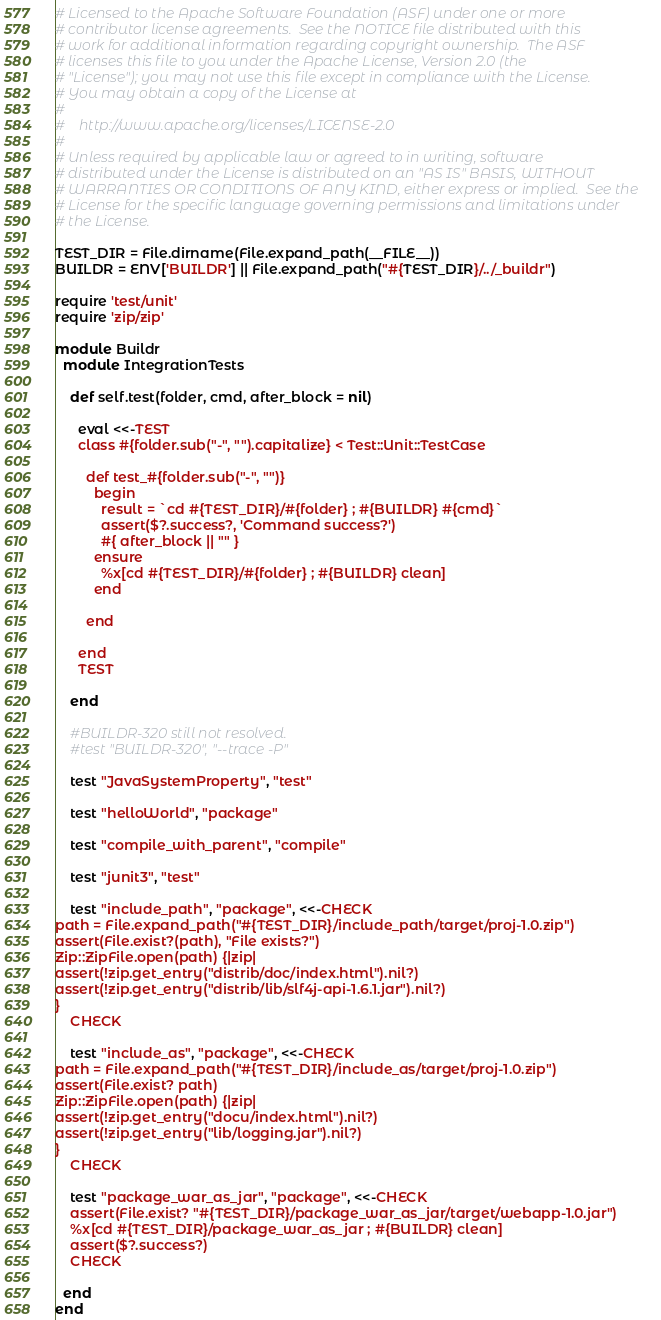Convert code to text. <code><loc_0><loc_0><loc_500><loc_500><_Ruby_># Licensed to the Apache Software Foundation (ASF) under one or more
# contributor license agreements.  See the NOTICE file distributed with this
# work for additional information regarding copyright ownership.  The ASF
# licenses this file to you under the Apache License, Version 2.0 (the
# "License"); you may not use this file except in compliance with the License.
# You may obtain a copy of the License at
#
#    http://www.apache.org/licenses/LICENSE-2.0
#
# Unless required by applicable law or agreed to in writing, software
# distributed under the License is distributed on an "AS IS" BASIS, WITHOUT
# WARRANTIES OR CONDITIONS OF ANY KIND, either express or implied.  See the
# License for the specific language governing permissions and limitations under
# the License.

TEST_DIR = File.dirname(File.expand_path(__FILE__))
BUILDR = ENV['BUILDR'] || File.expand_path("#{TEST_DIR}/../_buildr")

require 'test/unit'
require 'zip/zip'

module Buildr
  module IntegrationTests

    def self.test(folder, cmd, after_block = nil)

      eval <<-TEST
      class #{folder.sub("-", "").capitalize} < Test::Unit::TestCase

        def test_#{folder.sub("-", "")}
          begin
            result = `cd #{TEST_DIR}/#{folder} ; #{BUILDR} #{cmd}`
            assert($?.success?, 'Command success?')
            #{ after_block || "" }
          ensure
            %x[cd #{TEST_DIR}/#{folder} ; #{BUILDR} clean]
          end

        end

      end
      TEST

    end

    #BUILDR-320 still not resolved.
    #test "BUILDR-320", "--trace -P"

    test "JavaSystemProperty", "test"

    test "helloWorld", "package"

    test "compile_with_parent", "compile"

    test "junit3", "test"

    test "include_path", "package", <<-CHECK
path = File.expand_path("#{TEST_DIR}/include_path/target/proj-1.0.zip")
assert(File.exist?(path), "File exists?")
Zip::ZipFile.open(path) {|zip|
assert(!zip.get_entry("distrib/doc/index.html").nil?)
assert(!zip.get_entry("distrib/lib/slf4j-api-1.6.1.jar").nil?)
}
    CHECK

    test "include_as", "package", <<-CHECK
path = File.expand_path("#{TEST_DIR}/include_as/target/proj-1.0.zip")
assert(File.exist? path)
Zip::ZipFile.open(path) {|zip|
assert(!zip.get_entry("docu/index.html").nil?)
assert(!zip.get_entry("lib/logging.jar").nil?)
}
    CHECK

    test "package_war_as_jar", "package", <<-CHECK
    assert(File.exist? "#{TEST_DIR}/package_war_as_jar/target/webapp-1.0.jar")
    %x[cd #{TEST_DIR}/package_war_as_jar ; #{BUILDR} clean]
    assert($?.success?)
    CHECK

  end
end
</code> 